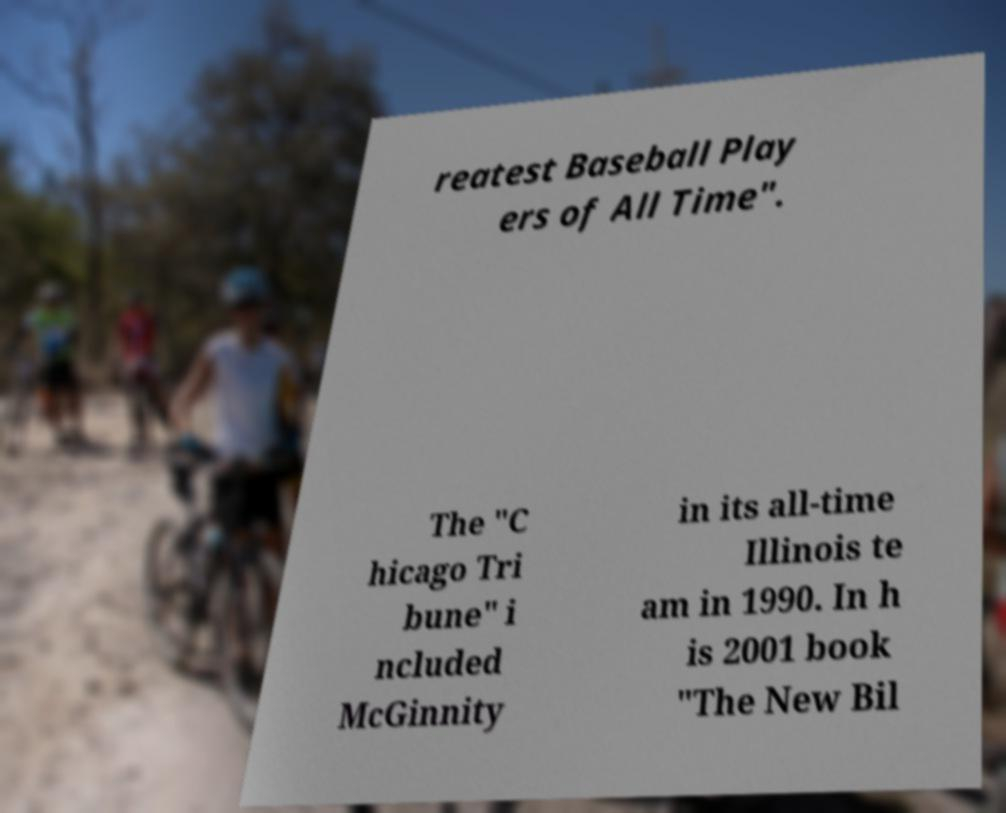What messages or text are displayed in this image? I need them in a readable, typed format. reatest Baseball Play ers of All Time". The "C hicago Tri bune" i ncluded McGinnity in its all-time Illinois te am in 1990. In h is 2001 book "The New Bil 